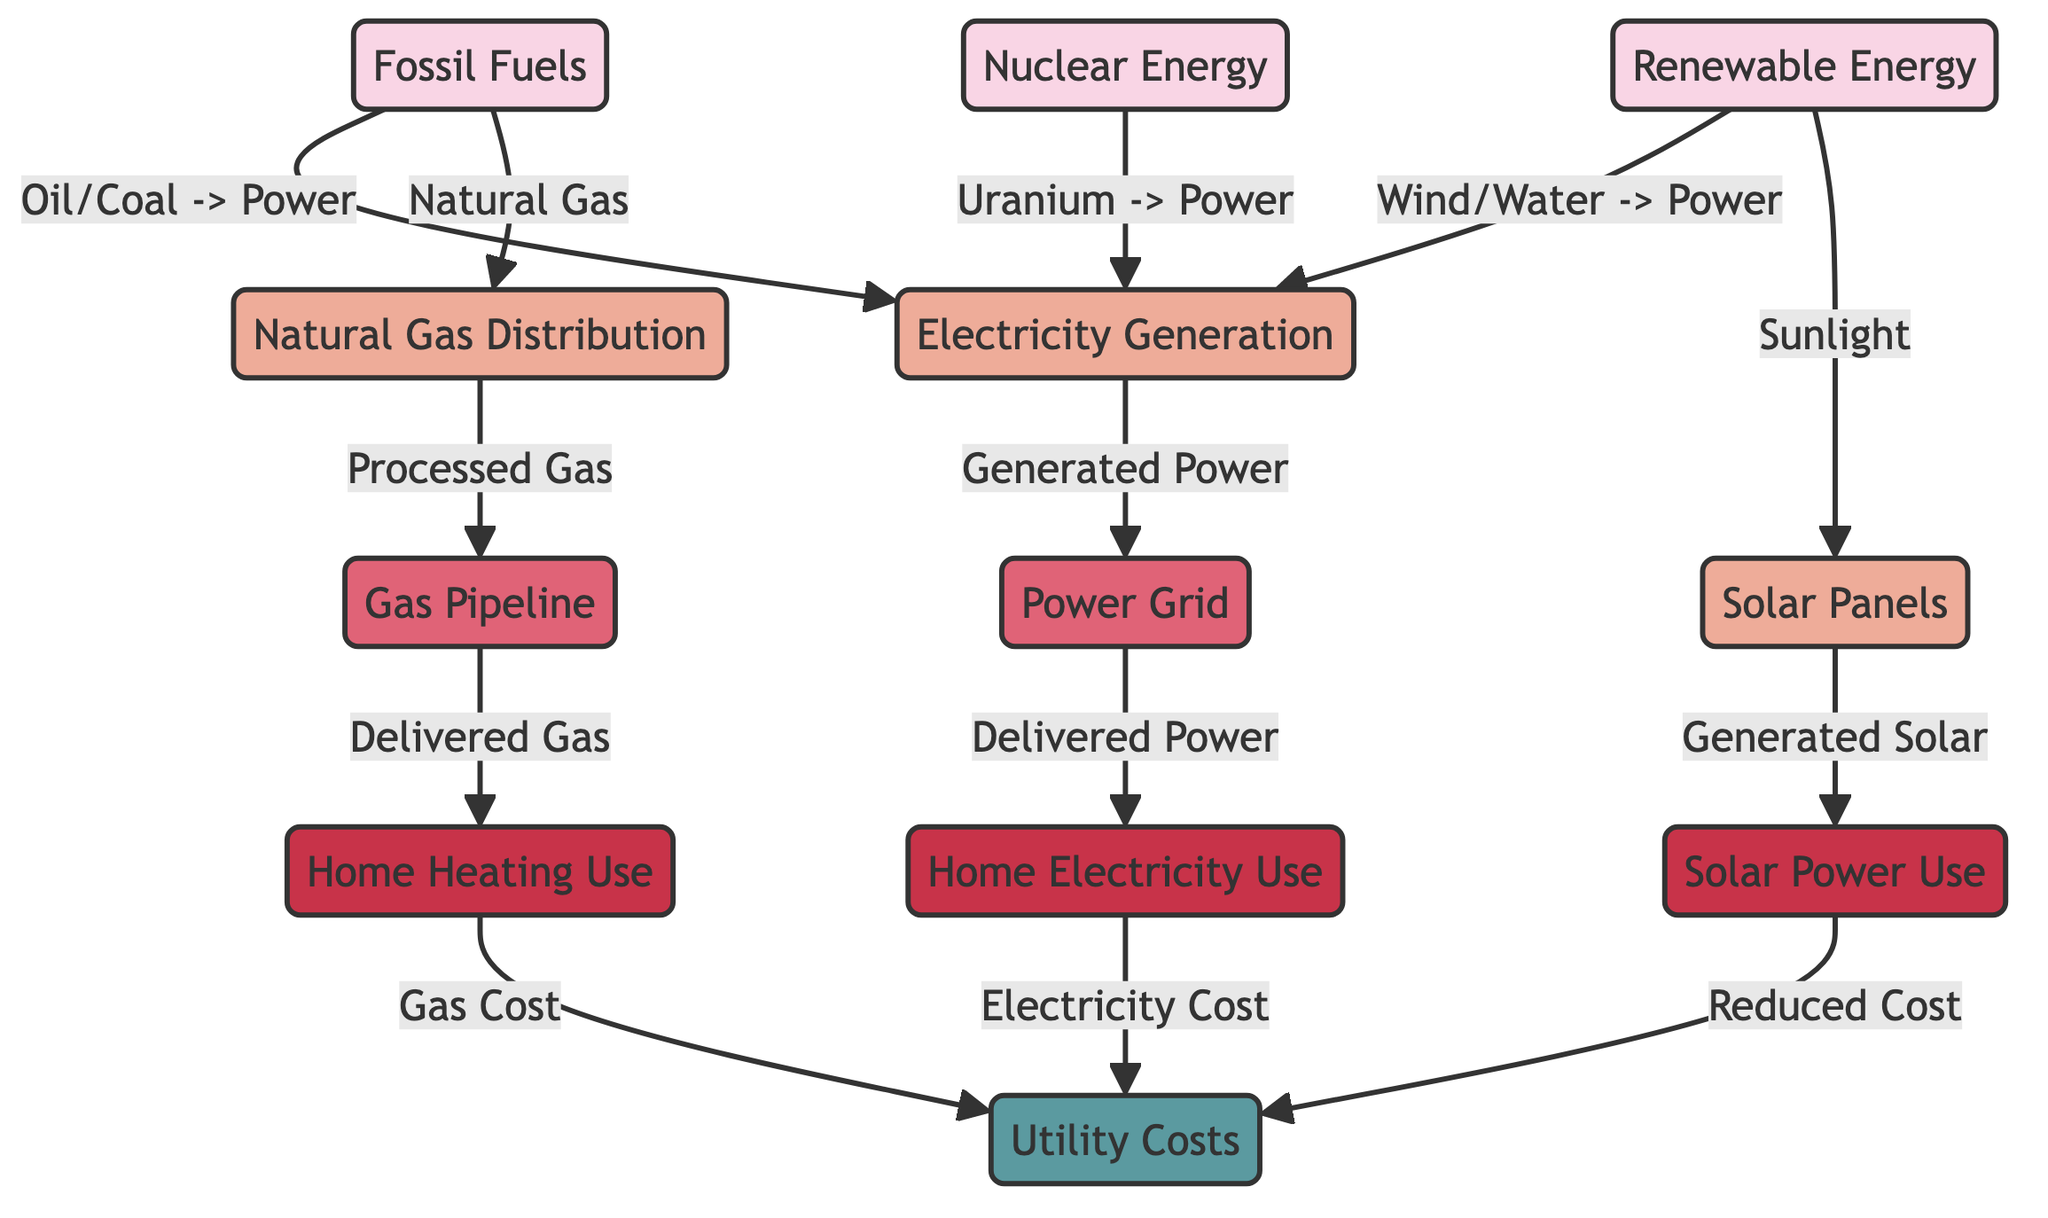What are the primary energy sources listed in the diagram? The diagram shows three primary energy sources: Fossil Fuels, Renewable Energy, and Nuclear Energy. These are the nodes at the beginning of the chain.
Answer: Fossil Fuels, Renewable Energy, Nuclear Energy What type of energy conversion is associated with Solar Panels? The diagram indicates that Solar Panels are linked to the conversion process for Renewable Energy, specifically generating Solar Power. This is represented by the "conversionSolar" node.
Answer: Solar Power How many types of energy distribution methods are shown? There are two distribution methods in the diagram: Power Grid and Gas Pipeline. These are the nodes that lead to the residences, indicating how energy reaches them.
Answer: 2 Which energy source leads to Heating Use in homes? The diagram shows that Natural Gas, derived from Fossil Fuels, leads directly to residence Heating Use. This is illustrated by the connection from "conversionGas" to "residenceHeatingUse."
Answer: Natural Gas What impact does home Solar Power Use have on Utility Costs? According to the diagram, home Solar Power Use leads to Reduced Cost in Utility Costs. This means that utilizing solar energy decreases the overall utility expenses.
Answer: Reduced Cost How many total conversion processes are present in the diagram? The diagram illustrates three conversion processes: Electricity Generation, Natural Gas Distribution, and Solar Panels for energy conversion. Counting these nodes gives a total of three conversion methods.
Answer: 3 What type of energy source provides Delivered Power to residences? The diagram indicates that Delivered Power to homes comes from the Power Grid, which is fed by converted power generated from Fossil Fuels, Renewable Energy, and Nuclear Energy.
Answer: Power Grid Which energy source is most linked to high Utility Costs? The diagram suggests that both Electricity Cost (from Electric Use) and Gas Cost (from Heating Use) contribute directly to Utility Costs, making Fossil Fuels likely the most linked source as they are connected to both Electricity and Heat.
Answer: Fossil Fuels 